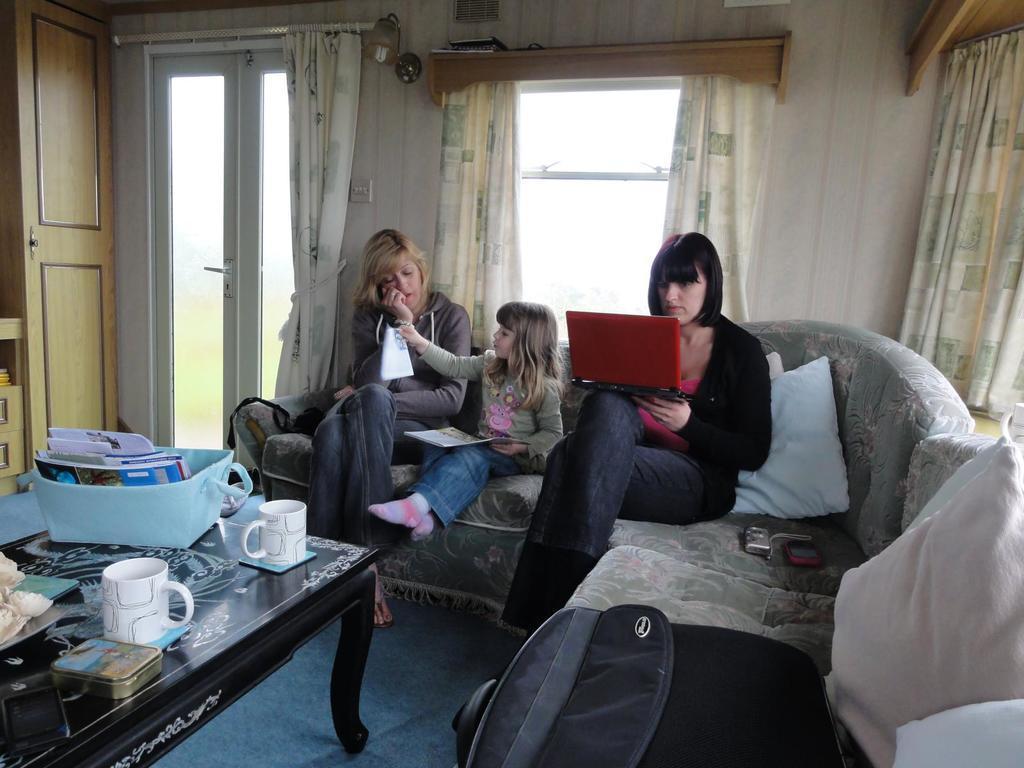Can you describe this image briefly? In this we can see the inside view of the living room in which two women and a small girl is sitting on the sofa. On the right we can see a woman wearing black t- shirt holding the red color laptop is seeing in it. Middle we can see the a small girl is playing and on the left a woman grey t- shirt placing her hand on the cheek and sleeping. Behind we can see the glass door and curtains. In the front a center table on which files and papers are placed in the blue gray and white tea cup. 